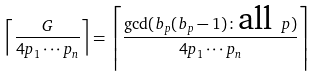Convert formula to latex. <formula><loc_0><loc_0><loc_500><loc_500>\left \lceil \frac { G } { 4 p _ { 1 } \cdots p _ { n } } \right \rceil = \left \lceil \frac { \gcd ( b _ { p } ( b _ { p } - 1 ) \colon \text {all } p ) } { 4 p _ { 1 } \cdots p _ { n } } \right \rceil</formula> 